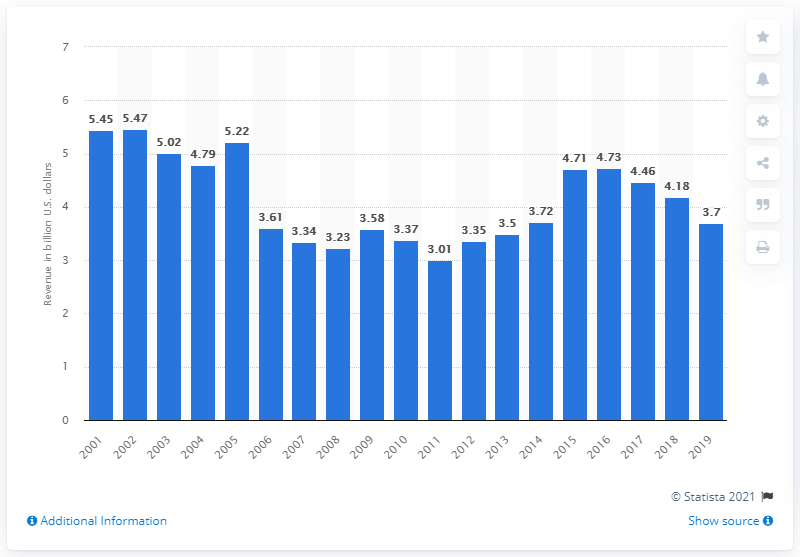List a handful of essential elements in this visual. Electrolux's revenue in the United States from 2001 to 2019 was approximately 3.7 billion USD. 